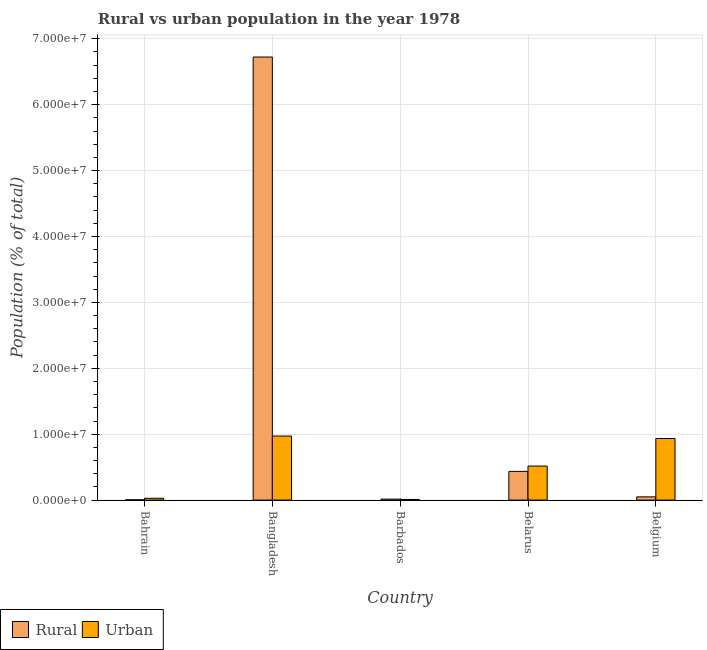How many different coloured bars are there?
Ensure brevity in your answer.  2. Are the number of bars on each tick of the X-axis equal?
Make the answer very short. Yes. What is the label of the 1st group of bars from the left?
Offer a terse response. Bahrain. What is the rural population density in Barbados?
Your answer should be compact. 1.52e+05. Across all countries, what is the maximum rural population density?
Give a very brief answer. 6.72e+07. Across all countries, what is the minimum rural population density?
Your answer should be very brief. 4.64e+04. In which country was the rural population density maximum?
Offer a terse response. Bangladesh. In which country was the rural population density minimum?
Provide a short and direct response. Bahrain. What is the total urban population density in the graph?
Provide a succinct answer. 2.46e+07. What is the difference between the rural population density in Bahrain and that in Bangladesh?
Offer a terse response. -6.72e+07. What is the difference between the urban population density in Belgium and the rural population density in Barbados?
Your answer should be compact. 9.20e+06. What is the average urban population density per country?
Your answer should be compact. 4.92e+06. What is the difference between the rural population density and urban population density in Bangladesh?
Ensure brevity in your answer.  5.75e+07. What is the ratio of the urban population density in Barbados to that in Belarus?
Offer a very short reply. 0.02. Is the urban population density in Bangladesh less than that in Belarus?
Provide a short and direct response. No. What is the difference between the highest and the second highest rural population density?
Ensure brevity in your answer.  6.29e+07. What is the difference between the highest and the lowest rural population density?
Keep it short and to the point. 6.72e+07. What does the 2nd bar from the left in Barbados represents?
Provide a succinct answer. Urban. What does the 1st bar from the right in Belgium represents?
Make the answer very short. Urban. How many bars are there?
Provide a succinct answer. 10. Are all the bars in the graph horizontal?
Make the answer very short. No. How many countries are there in the graph?
Your response must be concise. 5. Does the graph contain any zero values?
Your response must be concise. No. Does the graph contain grids?
Give a very brief answer. Yes. Where does the legend appear in the graph?
Keep it short and to the point. Bottom left. How are the legend labels stacked?
Your response must be concise. Horizontal. What is the title of the graph?
Keep it short and to the point. Rural vs urban population in the year 1978. What is the label or title of the Y-axis?
Offer a very short reply. Population (% of total). What is the Population (% of total) in Rural in Bahrain?
Provide a short and direct response. 4.64e+04. What is the Population (% of total) in Urban in Bahrain?
Offer a terse response. 2.77e+05. What is the Population (% of total) of Rural in Bangladesh?
Provide a succinct answer. 6.72e+07. What is the Population (% of total) of Urban in Bangladesh?
Make the answer very short. 9.72e+06. What is the Population (% of total) in Rural in Barbados?
Make the answer very short. 1.52e+05. What is the Population (% of total) of Urban in Barbados?
Keep it short and to the point. 9.82e+04. What is the Population (% of total) in Rural in Belarus?
Keep it short and to the point. 4.36e+06. What is the Population (% of total) of Urban in Belarus?
Make the answer very short. 5.17e+06. What is the Population (% of total) in Rural in Belgium?
Provide a succinct answer. 4.91e+05. What is the Population (% of total) of Urban in Belgium?
Provide a succinct answer. 9.35e+06. Across all countries, what is the maximum Population (% of total) in Rural?
Provide a succinct answer. 6.72e+07. Across all countries, what is the maximum Population (% of total) of Urban?
Your answer should be very brief. 9.72e+06. Across all countries, what is the minimum Population (% of total) in Rural?
Offer a terse response. 4.64e+04. Across all countries, what is the minimum Population (% of total) in Urban?
Make the answer very short. 9.82e+04. What is the total Population (% of total) of Rural in the graph?
Offer a terse response. 7.23e+07. What is the total Population (% of total) in Urban in the graph?
Keep it short and to the point. 2.46e+07. What is the difference between the Population (% of total) of Rural in Bahrain and that in Bangladesh?
Keep it short and to the point. -6.72e+07. What is the difference between the Population (% of total) in Urban in Bahrain and that in Bangladesh?
Make the answer very short. -9.44e+06. What is the difference between the Population (% of total) in Rural in Bahrain and that in Barbados?
Offer a very short reply. -1.05e+05. What is the difference between the Population (% of total) of Urban in Bahrain and that in Barbados?
Provide a short and direct response. 1.79e+05. What is the difference between the Population (% of total) of Rural in Bahrain and that in Belarus?
Provide a short and direct response. -4.31e+06. What is the difference between the Population (% of total) in Urban in Bahrain and that in Belarus?
Provide a short and direct response. -4.89e+06. What is the difference between the Population (% of total) of Rural in Bahrain and that in Belgium?
Provide a short and direct response. -4.45e+05. What is the difference between the Population (% of total) of Urban in Bahrain and that in Belgium?
Provide a short and direct response. -9.07e+06. What is the difference between the Population (% of total) of Rural in Bangladesh and that in Barbados?
Provide a short and direct response. 6.71e+07. What is the difference between the Population (% of total) in Urban in Bangladesh and that in Barbados?
Offer a very short reply. 9.62e+06. What is the difference between the Population (% of total) in Rural in Bangladesh and that in Belarus?
Give a very brief answer. 6.29e+07. What is the difference between the Population (% of total) in Urban in Bangladesh and that in Belarus?
Make the answer very short. 4.55e+06. What is the difference between the Population (% of total) in Rural in Bangladesh and that in Belgium?
Provide a short and direct response. 6.67e+07. What is the difference between the Population (% of total) of Urban in Bangladesh and that in Belgium?
Provide a short and direct response. 3.70e+05. What is the difference between the Population (% of total) in Rural in Barbados and that in Belarus?
Provide a succinct answer. -4.21e+06. What is the difference between the Population (% of total) of Urban in Barbados and that in Belarus?
Ensure brevity in your answer.  -5.07e+06. What is the difference between the Population (% of total) of Rural in Barbados and that in Belgium?
Keep it short and to the point. -3.40e+05. What is the difference between the Population (% of total) in Urban in Barbados and that in Belgium?
Your answer should be compact. -9.25e+06. What is the difference between the Population (% of total) of Rural in Belarus and that in Belgium?
Give a very brief answer. 3.87e+06. What is the difference between the Population (% of total) of Urban in Belarus and that in Belgium?
Provide a short and direct response. -4.18e+06. What is the difference between the Population (% of total) in Rural in Bahrain and the Population (% of total) in Urban in Bangladesh?
Your answer should be very brief. -9.67e+06. What is the difference between the Population (% of total) in Rural in Bahrain and the Population (% of total) in Urban in Barbados?
Offer a very short reply. -5.18e+04. What is the difference between the Population (% of total) in Rural in Bahrain and the Population (% of total) in Urban in Belarus?
Give a very brief answer. -5.12e+06. What is the difference between the Population (% of total) in Rural in Bahrain and the Population (% of total) in Urban in Belgium?
Provide a succinct answer. -9.30e+06. What is the difference between the Population (% of total) in Rural in Bangladesh and the Population (% of total) in Urban in Barbados?
Offer a very short reply. 6.71e+07. What is the difference between the Population (% of total) of Rural in Bangladesh and the Population (% of total) of Urban in Belarus?
Your response must be concise. 6.21e+07. What is the difference between the Population (% of total) in Rural in Bangladesh and the Population (% of total) in Urban in Belgium?
Your answer should be very brief. 5.79e+07. What is the difference between the Population (% of total) of Rural in Barbados and the Population (% of total) of Urban in Belarus?
Provide a short and direct response. -5.02e+06. What is the difference between the Population (% of total) in Rural in Barbados and the Population (% of total) in Urban in Belgium?
Offer a terse response. -9.20e+06. What is the difference between the Population (% of total) of Rural in Belarus and the Population (% of total) of Urban in Belgium?
Ensure brevity in your answer.  -4.99e+06. What is the average Population (% of total) of Rural per country?
Provide a short and direct response. 1.45e+07. What is the average Population (% of total) of Urban per country?
Offer a very short reply. 4.92e+06. What is the difference between the Population (% of total) of Rural and Population (% of total) of Urban in Bahrain?
Offer a terse response. -2.31e+05. What is the difference between the Population (% of total) in Rural and Population (% of total) in Urban in Bangladesh?
Your response must be concise. 5.75e+07. What is the difference between the Population (% of total) of Rural and Population (% of total) of Urban in Barbados?
Offer a terse response. 5.36e+04. What is the difference between the Population (% of total) of Rural and Population (% of total) of Urban in Belarus?
Offer a very short reply. -8.09e+05. What is the difference between the Population (% of total) in Rural and Population (% of total) in Urban in Belgium?
Your answer should be compact. -8.86e+06. What is the ratio of the Population (% of total) in Rural in Bahrain to that in Bangladesh?
Provide a short and direct response. 0. What is the ratio of the Population (% of total) in Urban in Bahrain to that in Bangladesh?
Your answer should be very brief. 0.03. What is the ratio of the Population (% of total) of Rural in Bahrain to that in Barbados?
Offer a terse response. 0.31. What is the ratio of the Population (% of total) in Urban in Bahrain to that in Barbados?
Provide a succinct answer. 2.82. What is the ratio of the Population (% of total) in Rural in Bahrain to that in Belarus?
Offer a very short reply. 0.01. What is the ratio of the Population (% of total) in Urban in Bahrain to that in Belarus?
Keep it short and to the point. 0.05. What is the ratio of the Population (% of total) of Rural in Bahrain to that in Belgium?
Ensure brevity in your answer.  0.09. What is the ratio of the Population (% of total) of Urban in Bahrain to that in Belgium?
Offer a very short reply. 0.03. What is the ratio of the Population (% of total) of Rural in Bangladesh to that in Barbados?
Your answer should be compact. 442.78. What is the ratio of the Population (% of total) of Urban in Bangladesh to that in Barbados?
Provide a short and direct response. 98.96. What is the ratio of the Population (% of total) in Rural in Bangladesh to that in Belarus?
Make the answer very short. 15.43. What is the ratio of the Population (% of total) in Urban in Bangladesh to that in Belarus?
Provide a short and direct response. 1.88. What is the ratio of the Population (% of total) in Rural in Bangladesh to that in Belgium?
Ensure brevity in your answer.  136.79. What is the ratio of the Population (% of total) of Urban in Bangladesh to that in Belgium?
Ensure brevity in your answer.  1.04. What is the ratio of the Population (% of total) in Rural in Barbados to that in Belarus?
Your response must be concise. 0.03. What is the ratio of the Population (% of total) of Urban in Barbados to that in Belarus?
Your answer should be very brief. 0.02. What is the ratio of the Population (% of total) in Rural in Barbados to that in Belgium?
Your answer should be very brief. 0.31. What is the ratio of the Population (% of total) in Urban in Barbados to that in Belgium?
Keep it short and to the point. 0.01. What is the ratio of the Population (% of total) of Rural in Belarus to that in Belgium?
Keep it short and to the point. 8.87. What is the ratio of the Population (% of total) in Urban in Belarus to that in Belgium?
Your answer should be compact. 0.55. What is the difference between the highest and the second highest Population (% of total) of Rural?
Give a very brief answer. 6.29e+07. What is the difference between the highest and the second highest Population (% of total) of Urban?
Give a very brief answer. 3.70e+05. What is the difference between the highest and the lowest Population (% of total) of Rural?
Offer a terse response. 6.72e+07. What is the difference between the highest and the lowest Population (% of total) in Urban?
Give a very brief answer. 9.62e+06. 